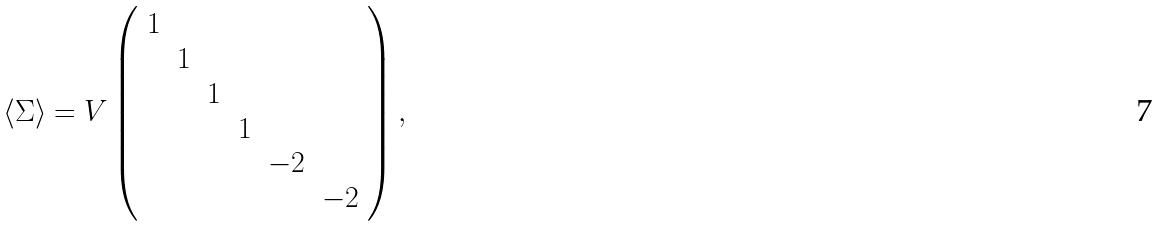Convert formula to latex. <formula><loc_0><loc_0><loc_500><loc_500>\langle \Sigma \rangle = V \left ( \begin{array} { c c c c c c } 1 & & & & & \\ & 1 & & & & \\ & & 1 & & & \\ & & & 1 & & \\ & & & & - 2 & \\ & & & & & - 2 \end{array} \right ) ,</formula> 